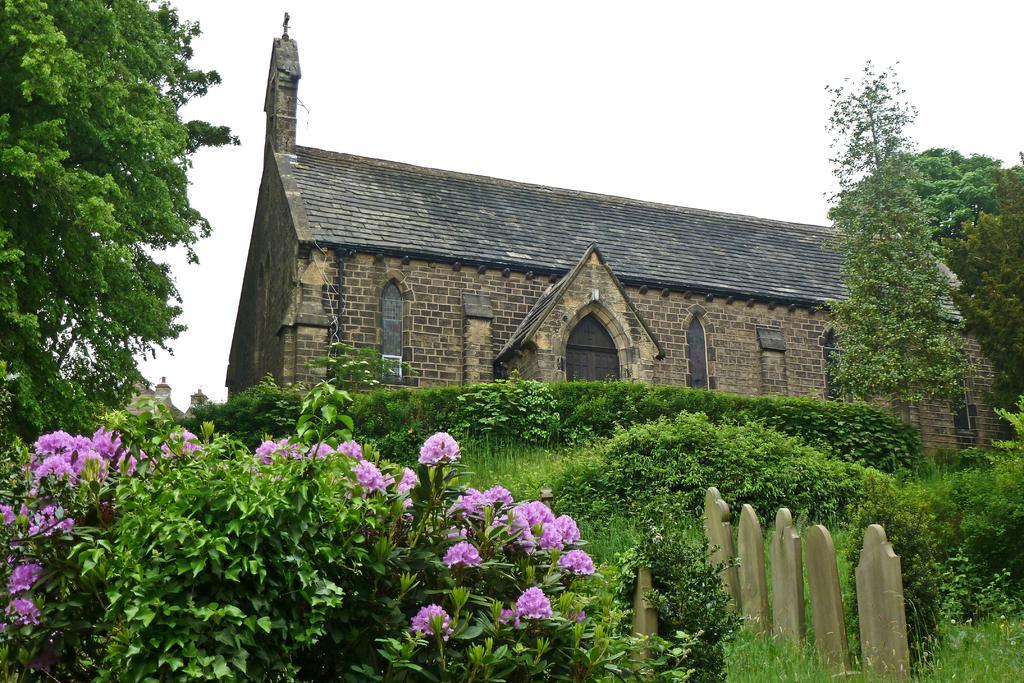Could you give a brief overview of what you see in this image? In this picture I can see plants, flowers, trees, there is a house, these are looking like stones, and in the background there is sky. 